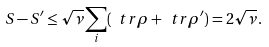<formula> <loc_0><loc_0><loc_500><loc_500>S - S ^ { \prime } \leq \sqrt { \nu } \sum _ { i } ( \ t r \rho + \ t r \rho ^ { \prime } ) = 2 \sqrt { \nu } \, .</formula> 